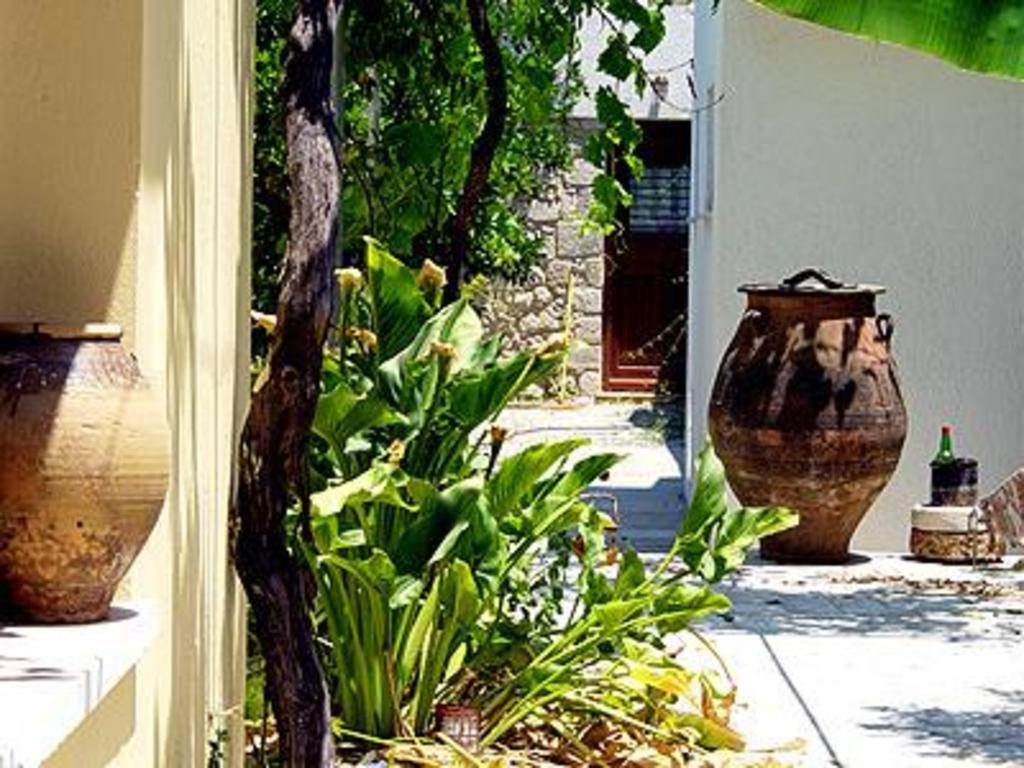What objects are present in the image that hold plants? There are vases in the image that hold plants. What type of living organisms can be seen in the image? Plants are visible in the image. What can be seen on the walls in the image? The walls are visible in the image. What is placed on the floor in the image? There is a bottle in a stand placed on the floor. Where is the leaf located in the image? A leaf is present at the top right of the image. What type of cherries can be heard in the image? There are no cherries present in the image, and therefore no sounds can be heard from them. What is the visibility of the mist in the image? There is no mist present in the image. 